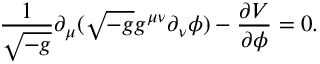Convert formula to latex. <formula><loc_0><loc_0><loc_500><loc_500>\frac { 1 } { \sqrt { - g } } \partial _ { \mu } ( \sqrt { - g } g ^ { \mu \nu } \partial _ { \nu } \phi ) - \frac { \partial V } { \partial \phi } = 0 .</formula> 